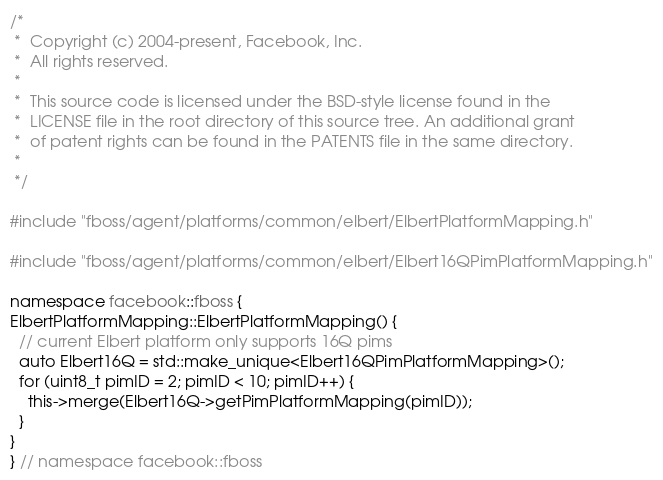Convert code to text. <code><loc_0><loc_0><loc_500><loc_500><_C++_>/*
 *  Copyright (c) 2004-present, Facebook, Inc.
 *  All rights reserved.
 *
 *  This source code is licensed under the BSD-style license found in the
 *  LICENSE file in the root directory of this source tree. An additional grant
 *  of patent rights can be found in the PATENTS file in the same directory.
 *
 */

#include "fboss/agent/platforms/common/elbert/ElbertPlatformMapping.h"

#include "fboss/agent/platforms/common/elbert/Elbert16QPimPlatformMapping.h"

namespace facebook::fboss {
ElbertPlatformMapping::ElbertPlatformMapping() {
  // current Elbert platform only supports 16Q pims
  auto Elbert16Q = std::make_unique<Elbert16QPimPlatformMapping>();
  for (uint8_t pimID = 2; pimID < 10; pimID++) {
    this->merge(Elbert16Q->getPimPlatformMapping(pimID));
  }
}
} // namespace facebook::fboss
</code> 